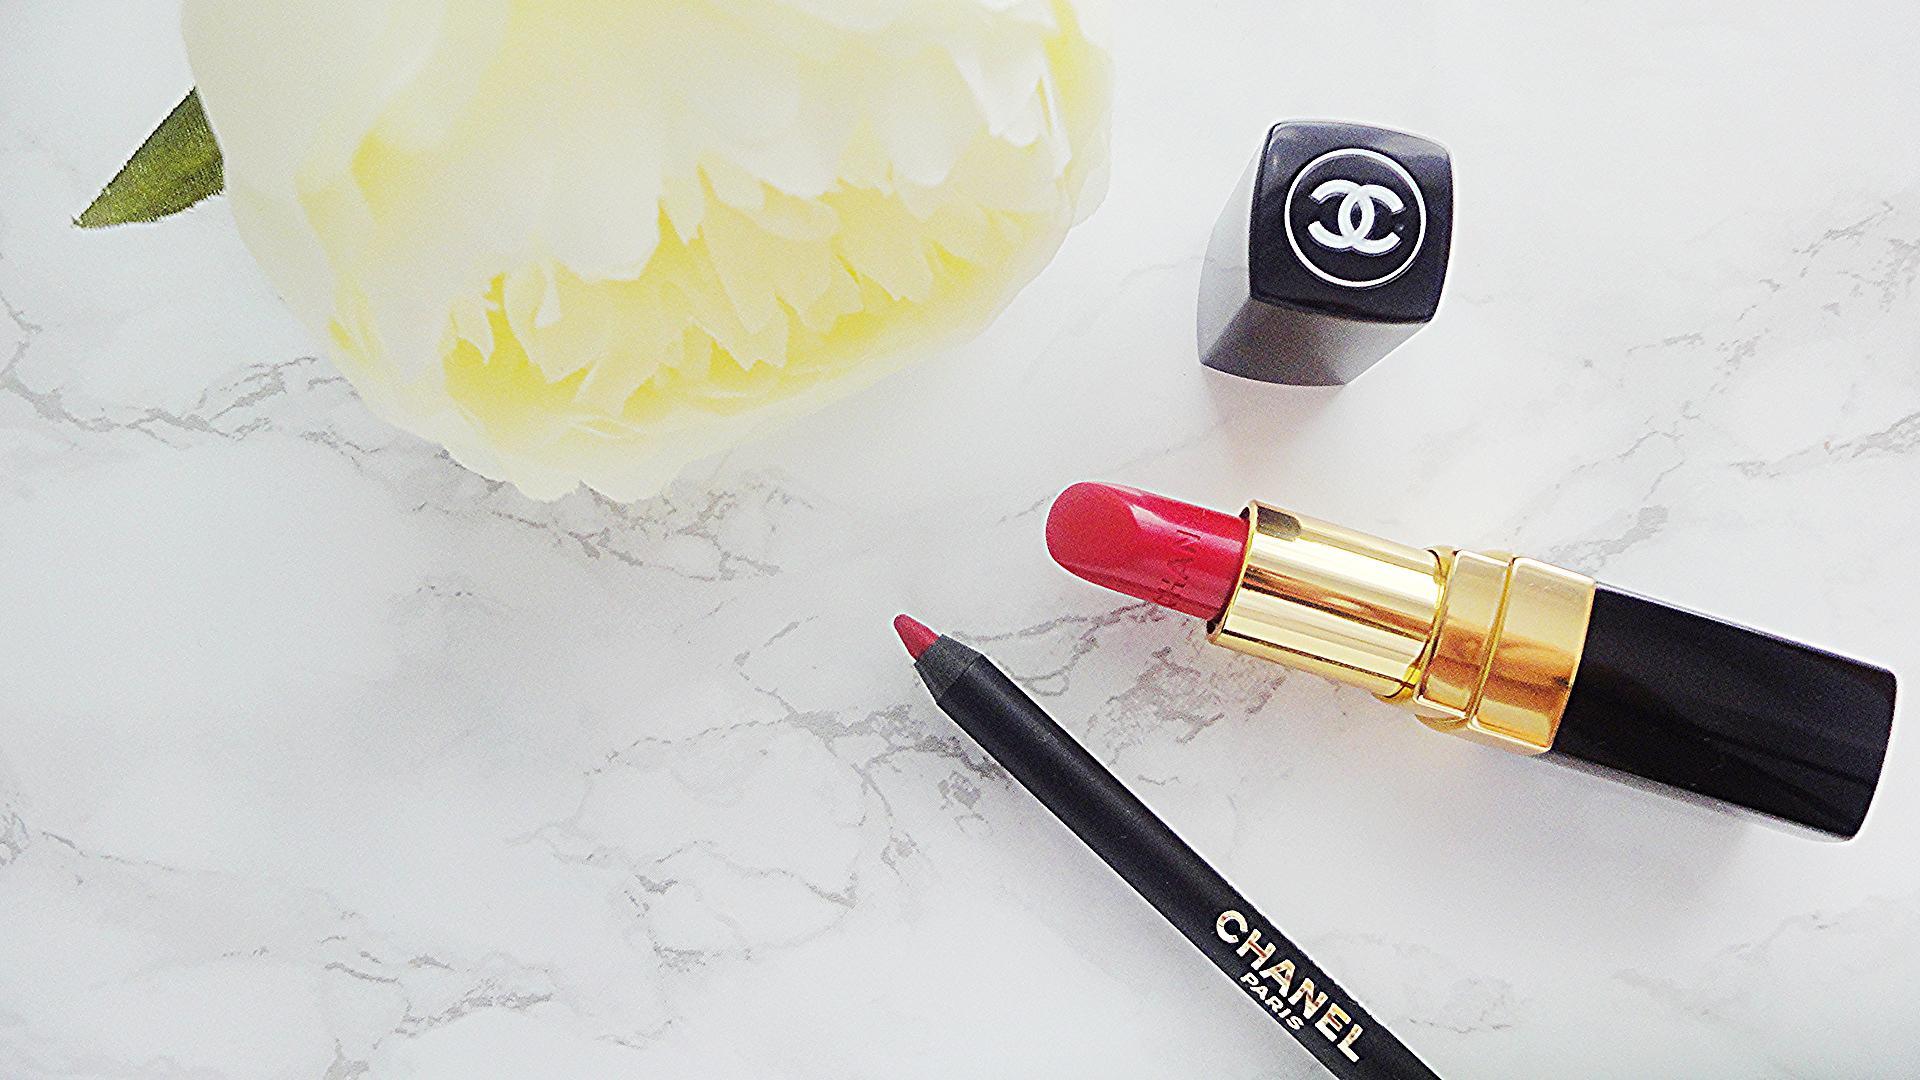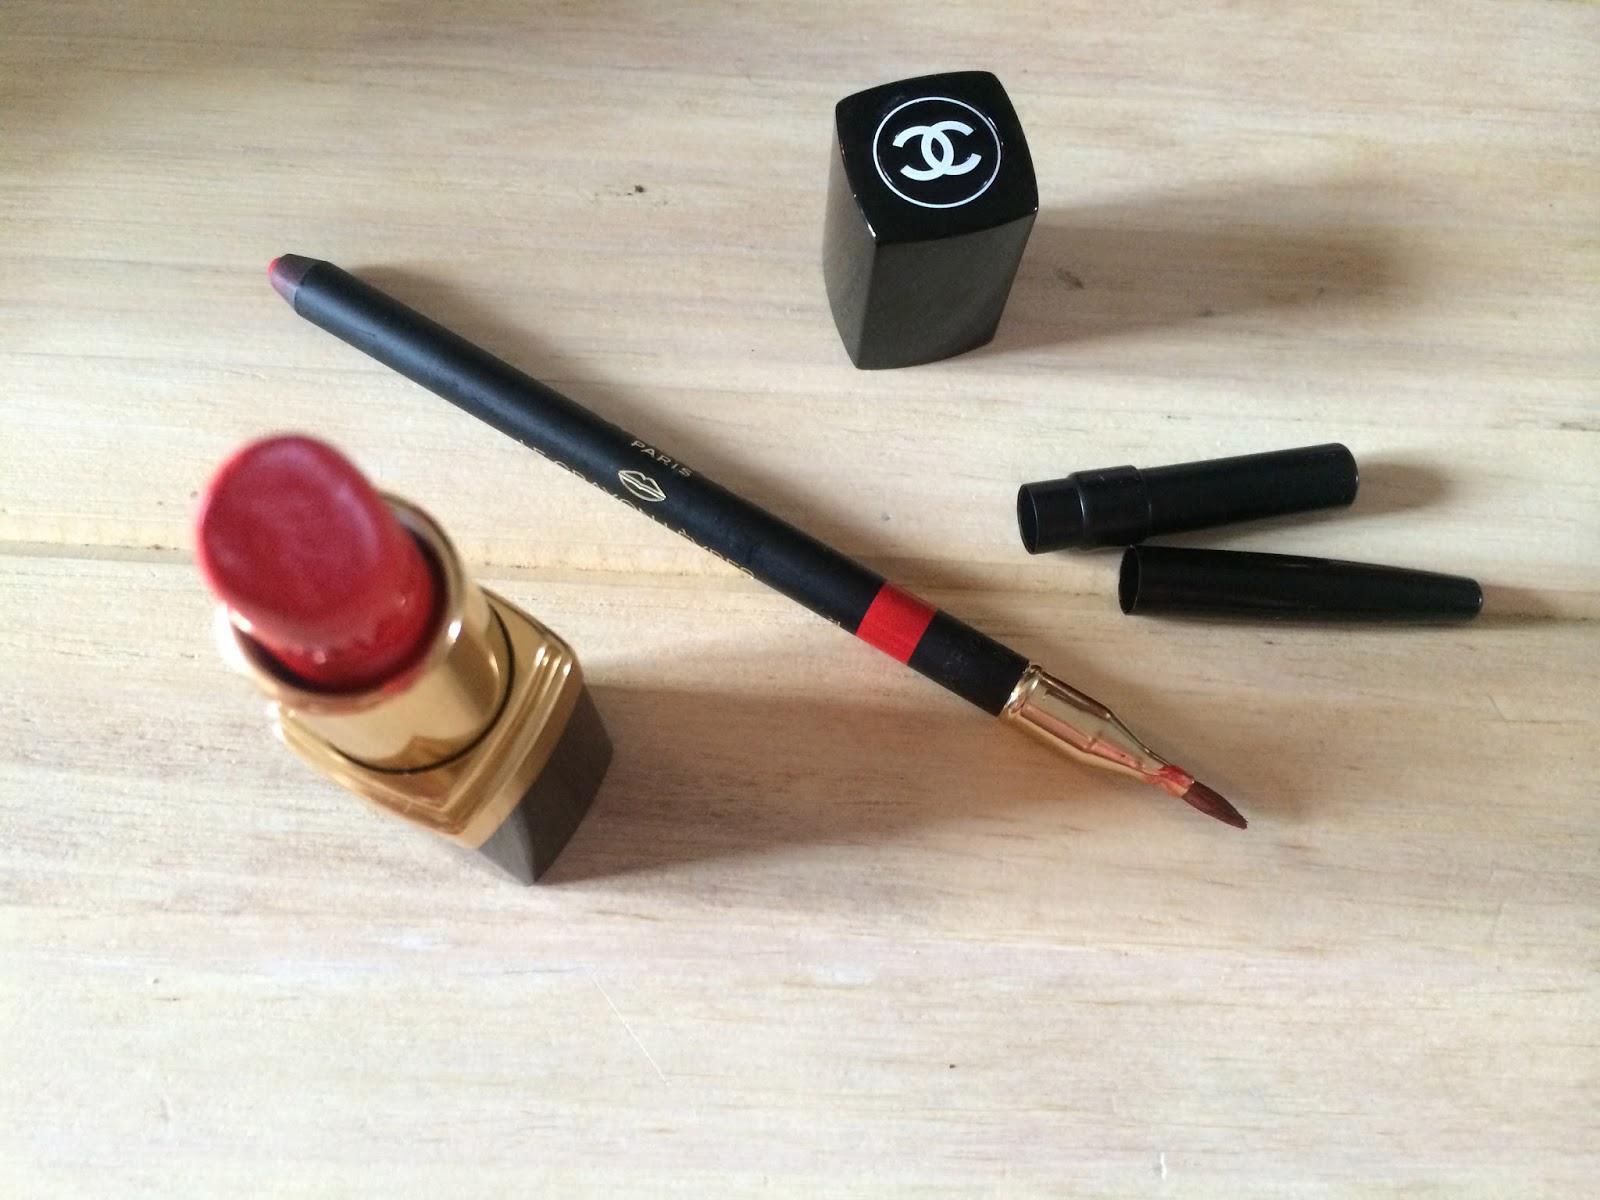The first image is the image on the left, the second image is the image on the right. Evaluate the accuracy of this statement regarding the images: "There is one tube of lipstick in each of the images.". Is it true? Answer yes or no. Yes. The first image is the image on the left, the second image is the image on the right. Examine the images to the left and right. Is the description "An image with a lip pencil and lipstick includes a creamy colored flower." accurate? Answer yes or no. Yes. 